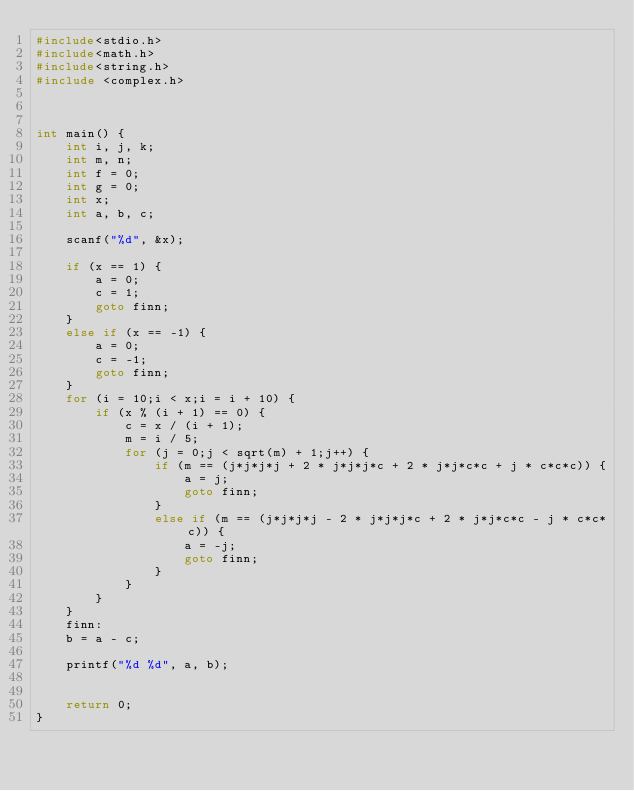<code> <loc_0><loc_0><loc_500><loc_500><_C_>#include<stdio.h>
#include<math.h>
#include<string.h>
#include <complex.h>



int main() {
	int i, j, k;
	int m, n;
	int f = 0;
	int g = 0;
	int x;
	int a, b, c;

	scanf("%d", &x);

	if (x == 1) {
		a = 0;
		c = 1;
		goto finn;
	}
	else if (x == -1) {
		a = 0;
		c = -1;
		goto finn;
	}
	for (i = 10;i < x;i = i + 10) {
		if (x % (i + 1) == 0) {
			c = x / (i + 1);
			m = i / 5;
			for (j = 0;j < sqrt(m) + 1;j++) {
				if (m == (j*j*j*j + 2 * j*j*j*c + 2 * j*j*c*c + j * c*c*c)) {
					a = j;
					goto finn;
				}
				else if (m == (j*j*j*j - 2 * j*j*j*c + 2 * j*j*c*c - j * c*c*c)) {
					a = -j;
					goto finn;
				}
			}
		}
	}
	finn:
	b = a - c;

	printf("%d %d", a, b);


	return 0;
}</code> 